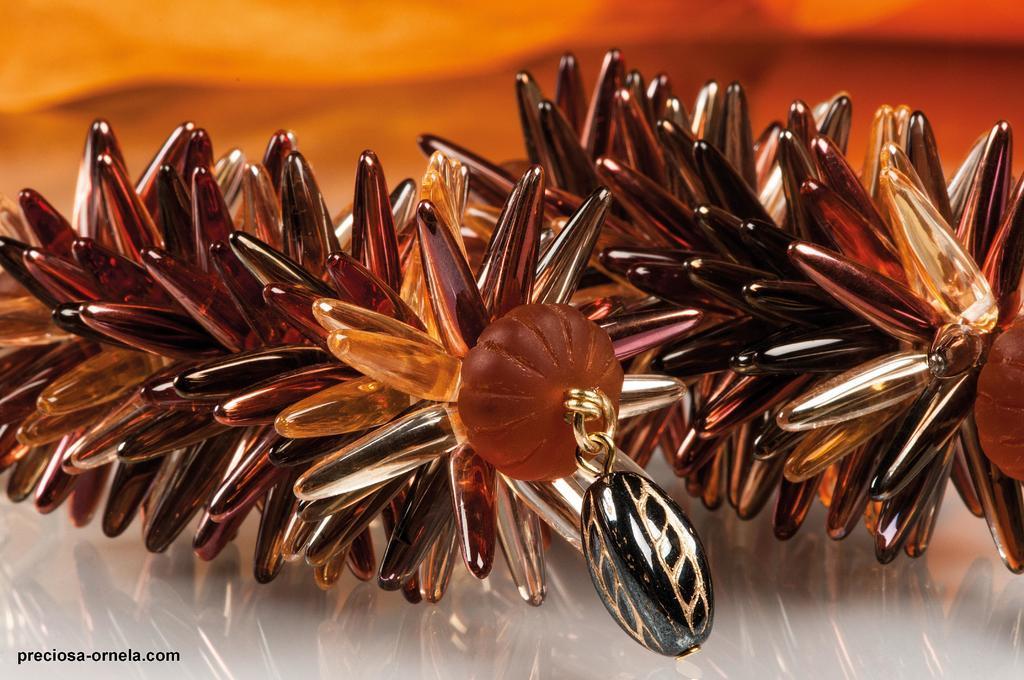Can you describe this image briefly? In this image, I can see a pair of earrings on an object. There is a blurred background. At the bottom left corner of the image, I can see a watermark. 